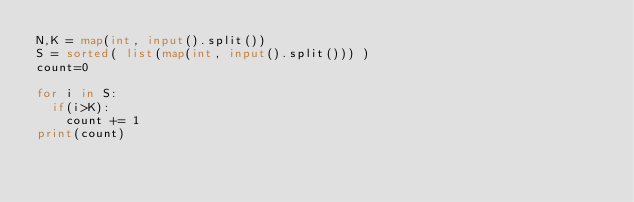Convert code to text. <code><loc_0><loc_0><loc_500><loc_500><_Python_>N,K = map(int, input().split())
S = sorted( list(map(int, input().split())) )
count=0

for i in S:
  if(i>K):
    count += 1
print(count)</code> 